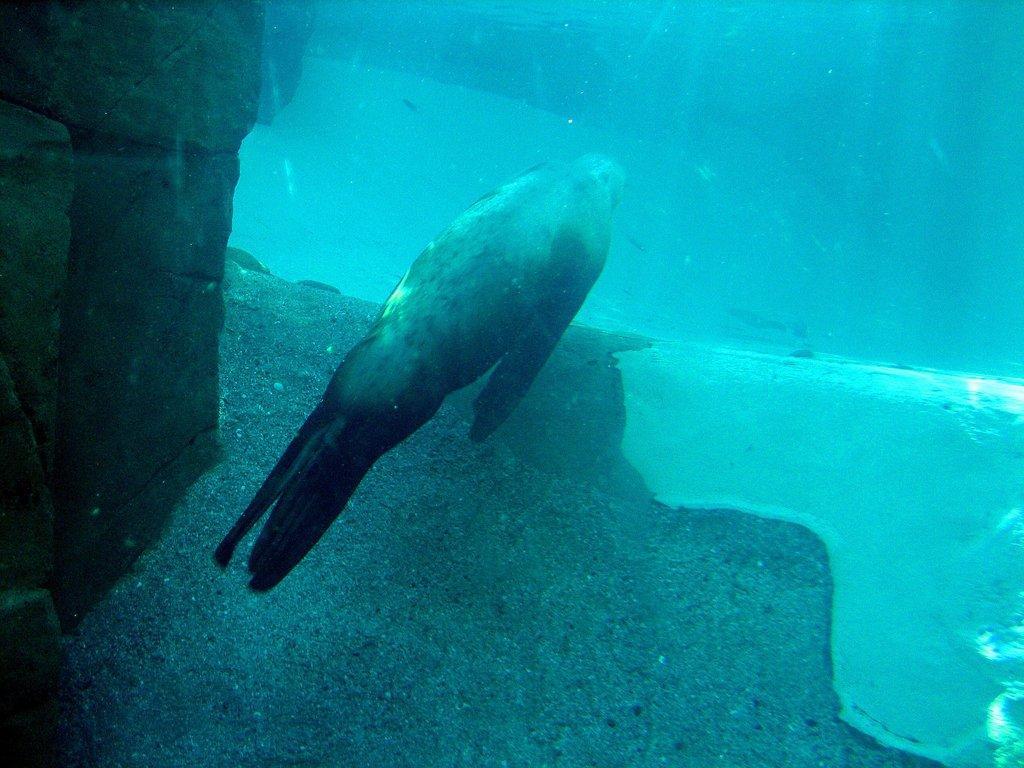Can you describe this image briefly? In the picture we can see deep inside the water with some rock and a fish with fins and tail. 